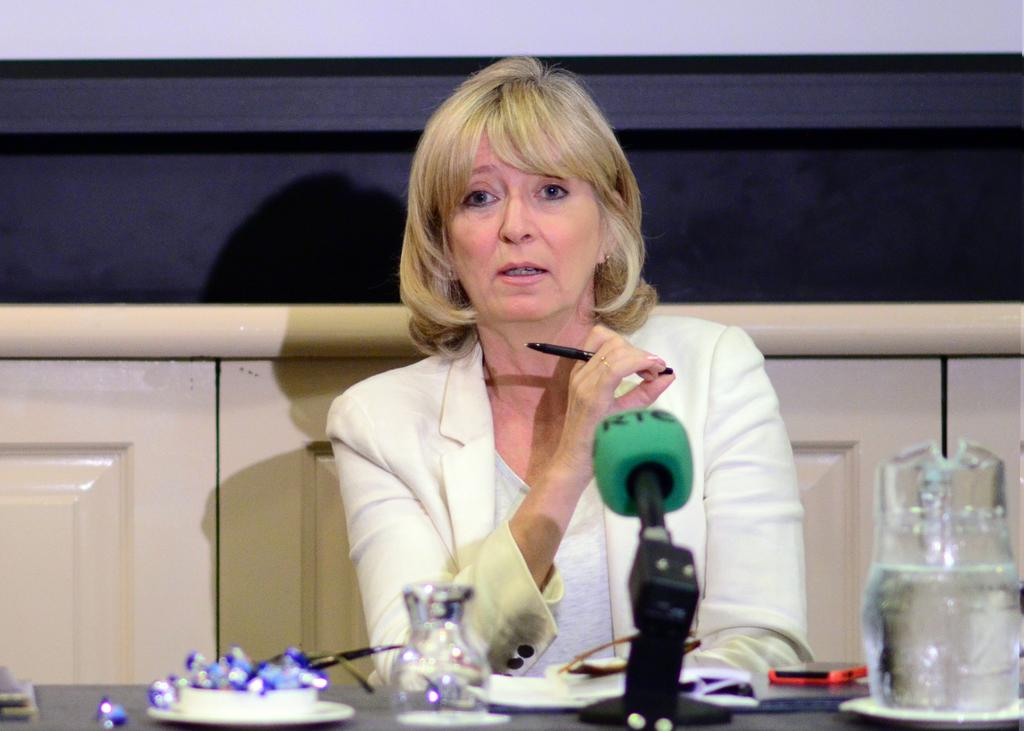<image>
Give a short and clear explanation of the subsequent image. A woman in an interview speaks into an "RTC" brand microphone. 